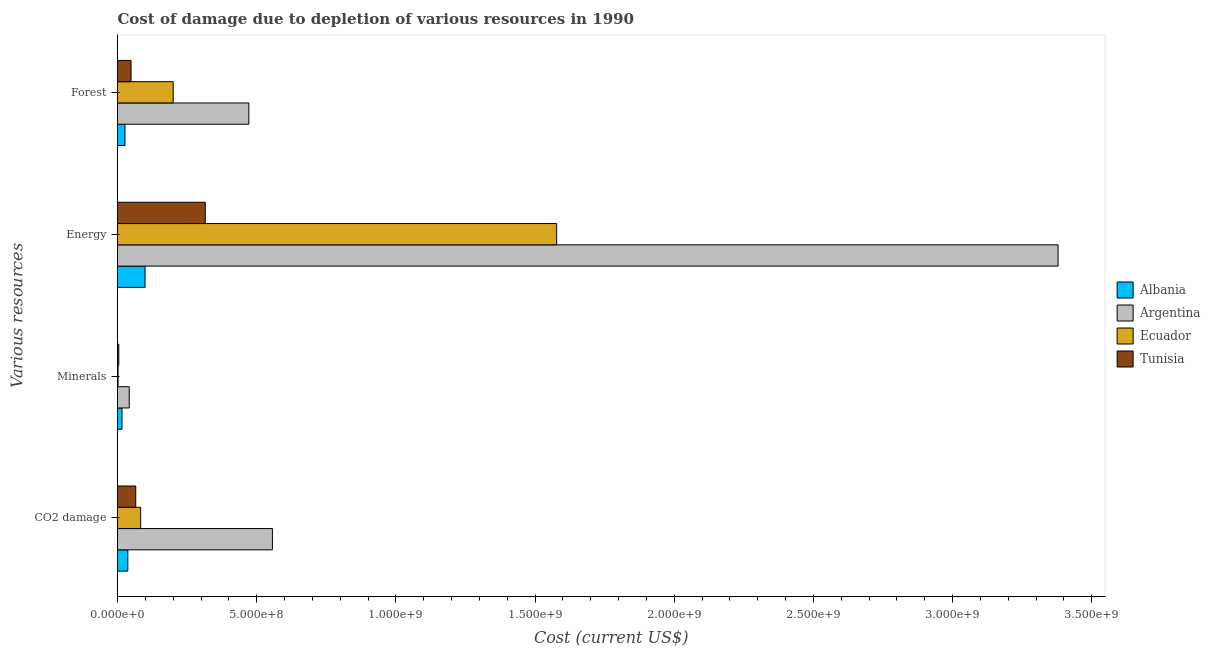How many different coloured bars are there?
Offer a terse response. 4. How many bars are there on the 4th tick from the top?
Keep it short and to the point. 4. How many bars are there on the 3rd tick from the bottom?
Offer a terse response. 4. What is the label of the 1st group of bars from the top?
Give a very brief answer. Forest. What is the cost of damage due to depletion of coal in Ecuador?
Provide a short and direct response. 8.32e+07. Across all countries, what is the maximum cost of damage due to depletion of forests?
Ensure brevity in your answer.  4.72e+08. Across all countries, what is the minimum cost of damage due to depletion of energy?
Keep it short and to the point. 9.89e+07. In which country was the cost of damage due to depletion of coal maximum?
Provide a succinct answer. Argentina. In which country was the cost of damage due to depletion of forests minimum?
Your answer should be very brief. Albania. What is the total cost of damage due to depletion of minerals in the graph?
Provide a succinct answer. 6.49e+07. What is the difference between the cost of damage due to depletion of forests in Albania and that in Tunisia?
Your answer should be compact. -2.18e+07. What is the difference between the cost of damage due to depletion of minerals in Tunisia and the cost of damage due to depletion of forests in Argentina?
Make the answer very short. -4.67e+08. What is the average cost of damage due to depletion of coal per country?
Ensure brevity in your answer.  1.86e+08. What is the difference between the cost of damage due to depletion of coal and cost of damage due to depletion of energy in Tunisia?
Make the answer very short. -2.50e+08. In how many countries, is the cost of damage due to depletion of forests greater than 3100000000 US$?
Make the answer very short. 0. What is the ratio of the cost of damage due to depletion of energy in Argentina to that in Ecuador?
Offer a very short reply. 2.14. Is the difference between the cost of damage due to depletion of energy in Ecuador and Albania greater than the difference between the cost of damage due to depletion of forests in Ecuador and Albania?
Your answer should be very brief. Yes. What is the difference between the highest and the second highest cost of damage due to depletion of energy?
Your response must be concise. 1.80e+09. What is the difference between the highest and the lowest cost of damage due to depletion of energy?
Offer a terse response. 3.28e+09. In how many countries, is the cost of damage due to depletion of energy greater than the average cost of damage due to depletion of energy taken over all countries?
Your answer should be compact. 2. Is the sum of the cost of damage due to depletion of energy in Ecuador and Tunisia greater than the maximum cost of damage due to depletion of coal across all countries?
Your response must be concise. Yes. What does the 4th bar from the top in Energy represents?
Provide a succinct answer. Albania. What does the 2nd bar from the bottom in Energy represents?
Provide a short and direct response. Argentina. How many countries are there in the graph?
Provide a short and direct response. 4. What is the difference between two consecutive major ticks on the X-axis?
Provide a short and direct response. 5.00e+08. Are the values on the major ticks of X-axis written in scientific E-notation?
Give a very brief answer. Yes. Does the graph contain grids?
Offer a very short reply. No. Where does the legend appear in the graph?
Keep it short and to the point. Center right. How many legend labels are there?
Offer a terse response. 4. How are the legend labels stacked?
Your answer should be very brief. Vertical. What is the title of the graph?
Give a very brief answer. Cost of damage due to depletion of various resources in 1990 . Does "Mauritania" appear as one of the legend labels in the graph?
Provide a short and direct response. No. What is the label or title of the X-axis?
Provide a short and direct response. Cost (current US$). What is the label or title of the Y-axis?
Offer a terse response. Various resources. What is the Cost (current US$) of Albania in CO2 damage?
Give a very brief answer. 3.70e+07. What is the Cost (current US$) of Argentina in CO2 damage?
Keep it short and to the point. 5.56e+08. What is the Cost (current US$) of Ecuador in CO2 damage?
Give a very brief answer. 8.32e+07. What is the Cost (current US$) in Tunisia in CO2 damage?
Your answer should be very brief. 6.56e+07. What is the Cost (current US$) of Albania in Minerals?
Provide a short and direct response. 1.62e+07. What is the Cost (current US$) of Argentina in Minerals?
Offer a terse response. 4.21e+07. What is the Cost (current US$) in Ecuador in Minerals?
Give a very brief answer. 2.14e+06. What is the Cost (current US$) of Tunisia in Minerals?
Your response must be concise. 4.58e+06. What is the Cost (current US$) in Albania in Energy?
Keep it short and to the point. 9.89e+07. What is the Cost (current US$) of Argentina in Energy?
Make the answer very short. 3.38e+09. What is the Cost (current US$) of Ecuador in Energy?
Offer a very short reply. 1.58e+09. What is the Cost (current US$) in Tunisia in Energy?
Make the answer very short. 3.15e+08. What is the Cost (current US$) of Albania in Forest?
Offer a very short reply. 2.68e+07. What is the Cost (current US$) of Argentina in Forest?
Your answer should be compact. 4.72e+08. What is the Cost (current US$) of Ecuador in Forest?
Make the answer very short. 2.00e+08. What is the Cost (current US$) in Tunisia in Forest?
Give a very brief answer. 4.87e+07. Across all Various resources, what is the maximum Cost (current US$) of Albania?
Offer a terse response. 9.89e+07. Across all Various resources, what is the maximum Cost (current US$) of Argentina?
Your answer should be compact. 3.38e+09. Across all Various resources, what is the maximum Cost (current US$) of Ecuador?
Offer a very short reply. 1.58e+09. Across all Various resources, what is the maximum Cost (current US$) of Tunisia?
Make the answer very short. 3.15e+08. Across all Various resources, what is the minimum Cost (current US$) in Albania?
Offer a terse response. 1.62e+07. Across all Various resources, what is the minimum Cost (current US$) of Argentina?
Ensure brevity in your answer.  4.21e+07. Across all Various resources, what is the minimum Cost (current US$) of Ecuador?
Your answer should be compact. 2.14e+06. Across all Various resources, what is the minimum Cost (current US$) in Tunisia?
Offer a very short reply. 4.58e+06. What is the total Cost (current US$) of Albania in the graph?
Ensure brevity in your answer.  1.79e+08. What is the total Cost (current US$) of Argentina in the graph?
Your answer should be very brief. 4.45e+09. What is the total Cost (current US$) of Ecuador in the graph?
Your answer should be compact. 1.86e+09. What is the total Cost (current US$) in Tunisia in the graph?
Your answer should be very brief. 4.34e+08. What is the difference between the Cost (current US$) in Albania in CO2 damage and that in Minerals?
Make the answer very short. 2.08e+07. What is the difference between the Cost (current US$) of Argentina in CO2 damage and that in Minerals?
Offer a terse response. 5.14e+08. What is the difference between the Cost (current US$) of Ecuador in CO2 damage and that in Minerals?
Your response must be concise. 8.11e+07. What is the difference between the Cost (current US$) of Tunisia in CO2 damage and that in Minerals?
Provide a succinct answer. 6.10e+07. What is the difference between the Cost (current US$) in Albania in CO2 damage and that in Energy?
Keep it short and to the point. -6.19e+07. What is the difference between the Cost (current US$) in Argentina in CO2 damage and that in Energy?
Provide a succinct answer. -2.82e+09. What is the difference between the Cost (current US$) in Ecuador in CO2 damage and that in Energy?
Offer a terse response. -1.49e+09. What is the difference between the Cost (current US$) in Tunisia in CO2 damage and that in Energy?
Provide a succinct answer. -2.50e+08. What is the difference between the Cost (current US$) of Albania in CO2 damage and that in Forest?
Keep it short and to the point. 1.02e+07. What is the difference between the Cost (current US$) in Argentina in CO2 damage and that in Forest?
Provide a succinct answer. 8.46e+07. What is the difference between the Cost (current US$) of Ecuador in CO2 damage and that in Forest?
Ensure brevity in your answer.  -1.17e+08. What is the difference between the Cost (current US$) in Tunisia in CO2 damage and that in Forest?
Your response must be concise. 1.69e+07. What is the difference between the Cost (current US$) in Albania in Minerals and that in Energy?
Make the answer very short. -8.27e+07. What is the difference between the Cost (current US$) of Argentina in Minerals and that in Energy?
Your answer should be very brief. -3.34e+09. What is the difference between the Cost (current US$) in Ecuador in Minerals and that in Energy?
Offer a terse response. -1.58e+09. What is the difference between the Cost (current US$) in Tunisia in Minerals and that in Energy?
Your response must be concise. -3.11e+08. What is the difference between the Cost (current US$) of Albania in Minerals and that in Forest?
Provide a short and direct response. -1.07e+07. What is the difference between the Cost (current US$) of Argentina in Minerals and that in Forest?
Your response must be concise. -4.30e+08. What is the difference between the Cost (current US$) in Ecuador in Minerals and that in Forest?
Your answer should be very brief. -1.98e+08. What is the difference between the Cost (current US$) of Tunisia in Minerals and that in Forest?
Give a very brief answer. -4.41e+07. What is the difference between the Cost (current US$) in Albania in Energy and that in Forest?
Your answer should be very brief. 7.20e+07. What is the difference between the Cost (current US$) of Argentina in Energy and that in Forest?
Make the answer very short. 2.91e+09. What is the difference between the Cost (current US$) of Ecuador in Energy and that in Forest?
Your answer should be compact. 1.38e+09. What is the difference between the Cost (current US$) in Tunisia in Energy and that in Forest?
Your answer should be compact. 2.67e+08. What is the difference between the Cost (current US$) in Albania in CO2 damage and the Cost (current US$) in Argentina in Minerals?
Provide a short and direct response. -5.07e+06. What is the difference between the Cost (current US$) of Albania in CO2 damage and the Cost (current US$) of Ecuador in Minerals?
Provide a succinct answer. 3.49e+07. What is the difference between the Cost (current US$) of Albania in CO2 damage and the Cost (current US$) of Tunisia in Minerals?
Keep it short and to the point. 3.24e+07. What is the difference between the Cost (current US$) in Argentina in CO2 damage and the Cost (current US$) in Ecuador in Minerals?
Provide a short and direct response. 5.54e+08. What is the difference between the Cost (current US$) of Argentina in CO2 damage and the Cost (current US$) of Tunisia in Minerals?
Your response must be concise. 5.52e+08. What is the difference between the Cost (current US$) of Ecuador in CO2 damage and the Cost (current US$) of Tunisia in Minerals?
Provide a succinct answer. 7.86e+07. What is the difference between the Cost (current US$) in Albania in CO2 damage and the Cost (current US$) in Argentina in Energy?
Keep it short and to the point. -3.34e+09. What is the difference between the Cost (current US$) of Albania in CO2 damage and the Cost (current US$) of Ecuador in Energy?
Your answer should be compact. -1.54e+09. What is the difference between the Cost (current US$) of Albania in CO2 damage and the Cost (current US$) of Tunisia in Energy?
Offer a very short reply. -2.78e+08. What is the difference between the Cost (current US$) of Argentina in CO2 damage and the Cost (current US$) of Ecuador in Energy?
Ensure brevity in your answer.  -1.02e+09. What is the difference between the Cost (current US$) in Argentina in CO2 damage and the Cost (current US$) in Tunisia in Energy?
Keep it short and to the point. 2.41e+08. What is the difference between the Cost (current US$) of Ecuador in CO2 damage and the Cost (current US$) of Tunisia in Energy?
Keep it short and to the point. -2.32e+08. What is the difference between the Cost (current US$) of Albania in CO2 damage and the Cost (current US$) of Argentina in Forest?
Offer a terse response. -4.35e+08. What is the difference between the Cost (current US$) of Albania in CO2 damage and the Cost (current US$) of Ecuador in Forest?
Provide a short and direct response. -1.63e+08. What is the difference between the Cost (current US$) in Albania in CO2 damage and the Cost (current US$) in Tunisia in Forest?
Your response must be concise. -1.17e+07. What is the difference between the Cost (current US$) in Argentina in CO2 damage and the Cost (current US$) in Ecuador in Forest?
Provide a succinct answer. 3.56e+08. What is the difference between the Cost (current US$) in Argentina in CO2 damage and the Cost (current US$) in Tunisia in Forest?
Keep it short and to the point. 5.08e+08. What is the difference between the Cost (current US$) of Ecuador in CO2 damage and the Cost (current US$) of Tunisia in Forest?
Keep it short and to the point. 3.45e+07. What is the difference between the Cost (current US$) in Albania in Minerals and the Cost (current US$) in Argentina in Energy?
Give a very brief answer. -3.36e+09. What is the difference between the Cost (current US$) in Albania in Minerals and the Cost (current US$) in Ecuador in Energy?
Your response must be concise. -1.56e+09. What is the difference between the Cost (current US$) of Albania in Minerals and the Cost (current US$) of Tunisia in Energy?
Give a very brief answer. -2.99e+08. What is the difference between the Cost (current US$) in Argentina in Minerals and the Cost (current US$) in Ecuador in Energy?
Make the answer very short. -1.54e+09. What is the difference between the Cost (current US$) in Argentina in Minerals and the Cost (current US$) in Tunisia in Energy?
Ensure brevity in your answer.  -2.73e+08. What is the difference between the Cost (current US$) of Ecuador in Minerals and the Cost (current US$) of Tunisia in Energy?
Make the answer very short. -3.13e+08. What is the difference between the Cost (current US$) of Albania in Minerals and the Cost (current US$) of Argentina in Forest?
Make the answer very short. -4.56e+08. What is the difference between the Cost (current US$) of Albania in Minerals and the Cost (current US$) of Ecuador in Forest?
Your answer should be compact. -1.84e+08. What is the difference between the Cost (current US$) of Albania in Minerals and the Cost (current US$) of Tunisia in Forest?
Provide a short and direct response. -3.25e+07. What is the difference between the Cost (current US$) of Argentina in Minerals and the Cost (current US$) of Ecuador in Forest?
Your answer should be compact. -1.58e+08. What is the difference between the Cost (current US$) of Argentina in Minerals and the Cost (current US$) of Tunisia in Forest?
Offer a very short reply. -6.58e+06. What is the difference between the Cost (current US$) of Ecuador in Minerals and the Cost (current US$) of Tunisia in Forest?
Give a very brief answer. -4.65e+07. What is the difference between the Cost (current US$) of Albania in Energy and the Cost (current US$) of Argentina in Forest?
Give a very brief answer. -3.73e+08. What is the difference between the Cost (current US$) in Albania in Energy and the Cost (current US$) in Ecuador in Forest?
Your answer should be compact. -1.01e+08. What is the difference between the Cost (current US$) of Albania in Energy and the Cost (current US$) of Tunisia in Forest?
Keep it short and to the point. 5.02e+07. What is the difference between the Cost (current US$) of Argentina in Energy and the Cost (current US$) of Ecuador in Forest?
Keep it short and to the point. 3.18e+09. What is the difference between the Cost (current US$) of Argentina in Energy and the Cost (current US$) of Tunisia in Forest?
Provide a short and direct response. 3.33e+09. What is the difference between the Cost (current US$) in Ecuador in Energy and the Cost (current US$) in Tunisia in Forest?
Make the answer very short. 1.53e+09. What is the average Cost (current US$) in Albania per Various resources?
Offer a terse response. 4.47e+07. What is the average Cost (current US$) of Argentina per Various resources?
Your answer should be very brief. 1.11e+09. What is the average Cost (current US$) of Ecuador per Various resources?
Your answer should be very brief. 4.66e+08. What is the average Cost (current US$) of Tunisia per Various resources?
Give a very brief answer. 1.09e+08. What is the difference between the Cost (current US$) of Albania and Cost (current US$) of Argentina in CO2 damage?
Give a very brief answer. -5.19e+08. What is the difference between the Cost (current US$) of Albania and Cost (current US$) of Ecuador in CO2 damage?
Make the answer very short. -4.62e+07. What is the difference between the Cost (current US$) in Albania and Cost (current US$) in Tunisia in CO2 damage?
Keep it short and to the point. -2.86e+07. What is the difference between the Cost (current US$) of Argentina and Cost (current US$) of Ecuador in CO2 damage?
Your response must be concise. 4.73e+08. What is the difference between the Cost (current US$) of Argentina and Cost (current US$) of Tunisia in CO2 damage?
Keep it short and to the point. 4.91e+08. What is the difference between the Cost (current US$) in Ecuador and Cost (current US$) in Tunisia in CO2 damage?
Your answer should be compact. 1.76e+07. What is the difference between the Cost (current US$) in Albania and Cost (current US$) in Argentina in Minerals?
Your answer should be compact. -2.59e+07. What is the difference between the Cost (current US$) in Albania and Cost (current US$) in Ecuador in Minerals?
Make the answer very short. 1.40e+07. What is the difference between the Cost (current US$) in Albania and Cost (current US$) in Tunisia in Minerals?
Make the answer very short. 1.16e+07. What is the difference between the Cost (current US$) of Argentina and Cost (current US$) of Ecuador in Minerals?
Provide a succinct answer. 3.99e+07. What is the difference between the Cost (current US$) in Argentina and Cost (current US$) in Tunisia in Minerals?
Ensure brevity in your answer.  3.75e+07. What is the difference between the Cost (current US$) of Ecuador and Cost (current US$) of Tunisia in Minerals?
Provide a short and direct response. -2.44e+06. What is the difference between the Cost (current US$) in Albania and Cost (current US$) in Argentina in Energy?
Ensure brevity in your answer.  -3.28e+09. What is the difference between the Cost (current US$) in Albania and Cost (current US$) in Ecuador in Energy?
Offer a terse response. -1.48e+09. What is the difference between the Cost (current US$) of Albania and Cost (current US$) of Tunisia in Energy?
Offer a terse response. -2.16e+08. What is the difference between the Cost (current US$) in Argentina and Cost (current US$) in Ecuador in Energy?
Your response must be concise. 1.80e+09. What is the difference between the Cost (current US$) of Argentina and Cost (current US$) of Tunisia in Energy?
Give a very brief answer. 3.06e+09. What is the difference between the Cost (current US$) of Ecuador and Cost (current US$) of Tunisia in Energy?
Offer a terse response. 1.26e+09. What is the difference between the Cost (current US$) in Albania and Cost (current US$) in Argentina in Forest?
Offer a terse response. -4.45e+08. What is the difference between the Cost (current US$) of Albania and Cost (current US$) of Ecuador in Forest?
Make the answer very short. -1.73e+08. What is the difference between the Cost (current US$) of Albania and Cost (current US$) of Tunisia in Forest?
Make the answer very short. -2.18e+07. What is the difference between the Cost (current US$) of Argentina and Cost (current US$) of Ecuador in Forest?
Give a very brief answer. 2.72e+08. What is the difference between the Cost (current US$) of Argentina and Cost (current US$) of Tunisia in Forest?
Offer a terse response. 4.23e+08. What is the difference between the Cost (current US$) of Ecuador and Cost (current US$) of Tunisia in Forest?
Give a very brief answer. 1.51e+08. What is the ratio of the Cost (current US$) of Albania in CO2 damage to that in Minerals?
Provide a succinct answer. 2.29. What is the ratio of the Cost (current US$) in Argentina in CO2 damage to that in Minerals?
Keep it short and to the point. 13.23. What is the ratio of the Cost (current US$) of Ecuador in CO2 damage to that in Minerals?
Keep it short and to the point. 38.9. What is the ratio of the Cost (current US$) in Tunisia in CO2 damage to that in Minerals?
Your response must be concise. 14.32. What is the ratio of the Cost (current US$) in Albania in CO2 damage to that in Energy?
Give a very brief answer. 0.37. What is the ratio of the Cost (current US$) of Argentina in CO2 damage to that in Energy?
Give a very brief answer. 0.16. What is the ratio of the Cost (current US$) of Ecuador in CO2 damage to that in Energy?
Your answer should be very brief. 0.05. What is the ratio of the Cost (current US$) of Tunisia in CO2 damage to that in Energy?
Offer a terse response. 0.21. What is the ratio of the Cost (current US$) in Albania in CO2 damage to that in Forest?
Provide a short and direct response. 1.38. What is the ratio of the Cost (current US$) in Argentina in CO2 damage to that in Forest?
Provide a short and direct response. 1.18. What is the ratio of the Cost (current US$) of Ecuador in CO2 damage to that in Forest?
Provide a succinct answer. 0.42. What is the ratio of the Cost (current US$) of Tunisia in CO2 damage to that in Forest?
Give a very brief answer. 1.35. What is the ratio of the Cost (current US$) of Albania in Minerals to that in Energy?
Offer a very short reply. 0.16. What is the ratio of the Cost (current US$) of Argentina in Minerals to that in Energy?
Provide a succinct answer. 0.01. What is the ratio of the Cost (current US$) in Ecuador in Minerals to that in Energy?
Ensure brevity in your answer.  0. What is the ratio of the Cost (current US$) of Tunisia in Minerals to that in Energy?
Make the answer very short. 0.01. What is the ratio of the Cost (current US$) in Albania in Minerals to that in Forest?
Give a very brief answer. 0.6. What is the ratio of the Cost (current US$) of Argentina in Minerals to that in Forest?
Your answer should be very brief. 0.09. What is the ratio of the Cost (current US$) of Ecuador in Minerals to that in Forest?
Provide a short and direct response. 0.01. What is the ratio of the Cost (current US$) of Tunisia in Minerals to that in Forest?
Ensure brevity in your answer.  0.09. What is the ratio of the Cost (current US$) in Albania in Energy to that in Forest?
Provide a succinct answer. 3.69. What is the ratio of the Cost (current US$) of Argentina in Energy to that in Forest?
Make the answer very short. 7.16. What is the ratio of the Cost (current US$) of Ecuador in Energy to that in Forest?
Your response must be concise. 7.89. What is the ratio of the Cost (current US$) of Tunisia in Energy to that in Forest?
Your answer should be compact. 6.48. What is the difference between the highest and the second highest Cost (current US$) of Albania?
Offer a very short reply. 6.19e+07. What is the difference between the highest and the second highest Cost (current US$) in Argentina?
Offer a very short reply. 2.82e+09. What is the difference between the highest and the second highest Cost (current US$) of Ecuador?
Your response must be concise. 1.38e+09. What is the difference between the highest and the second highest Cost (current US$) of Tunisia?
Provide a succinct answer. 2.50e+08. What is the difference between the highest and the lowest Cost (current US$) of Albania?
Make the answer very short. 8.27e+07. What is the difference between the highest and the lowest Cost (current US$) in Argentina?
Offer a terse response. 3.34e+09. What is the difference between the highest and the lowest Cost (current US$) of Ecuador?
Provide a succinct answer. 1.58e+09. What is the difference between the highest and the lowest Cost (current US$) in Tunisia?
Your answer should be very brief. 3.11e+08. 